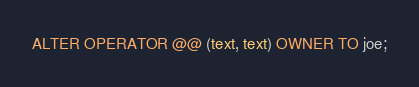<code> <loc_0><loc_0><loc_500><loc_500><_SQL_>ALTER OPERATOR @@ (text, text) OWNER TO joe;
</code> 